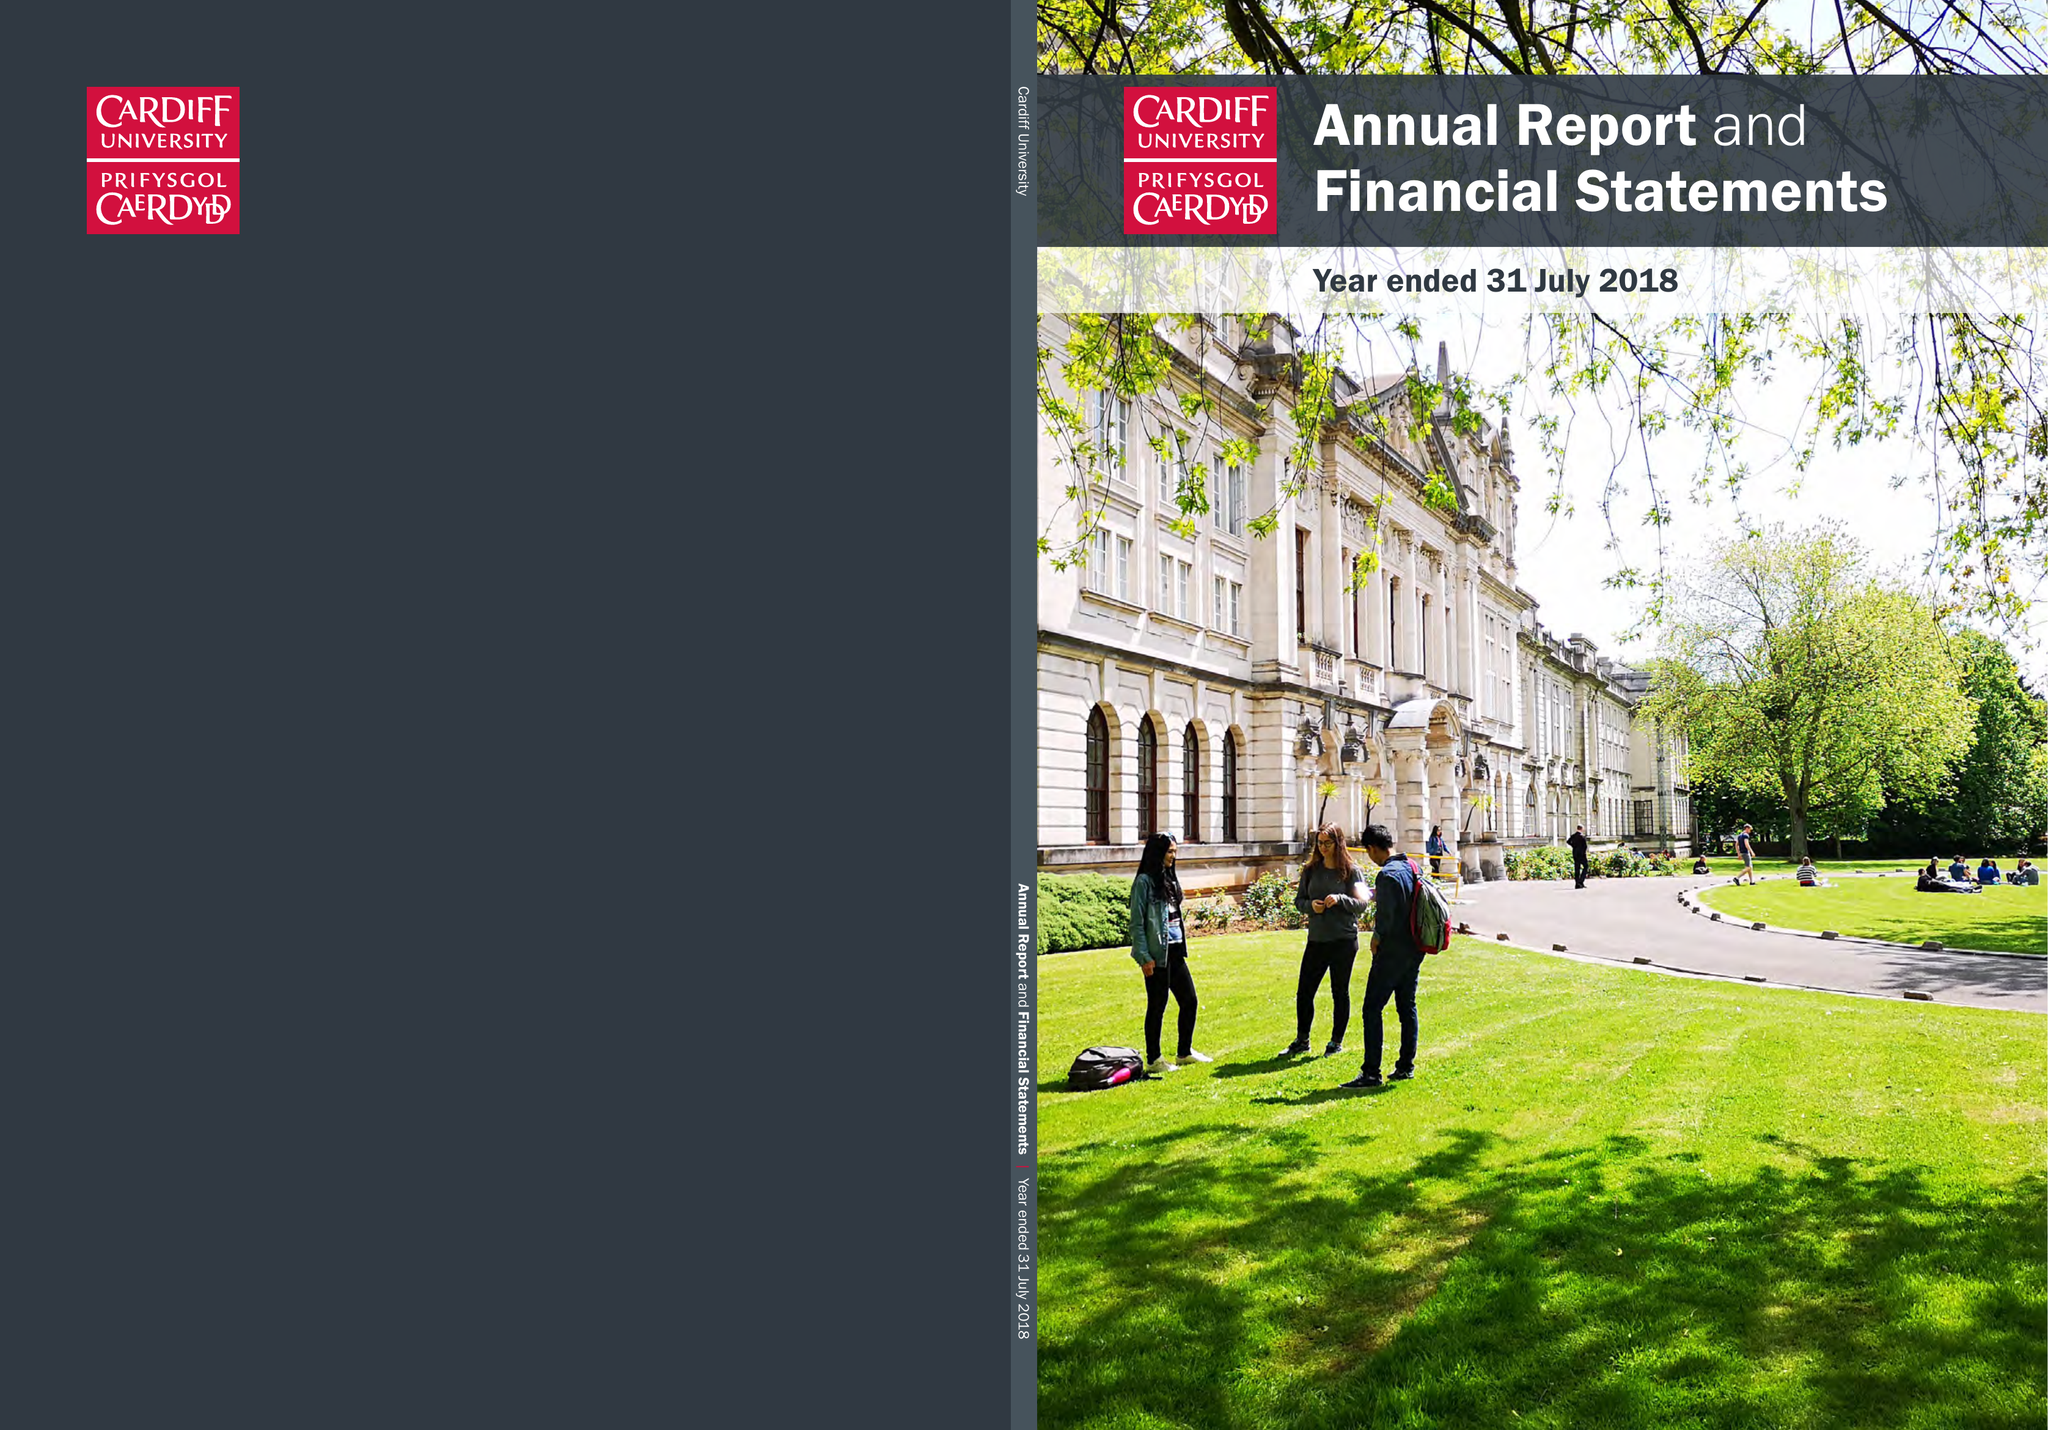What is the value for the spending_annually_in_british_pounds?
Answer the question using a single word or phrase. 540488000.00 